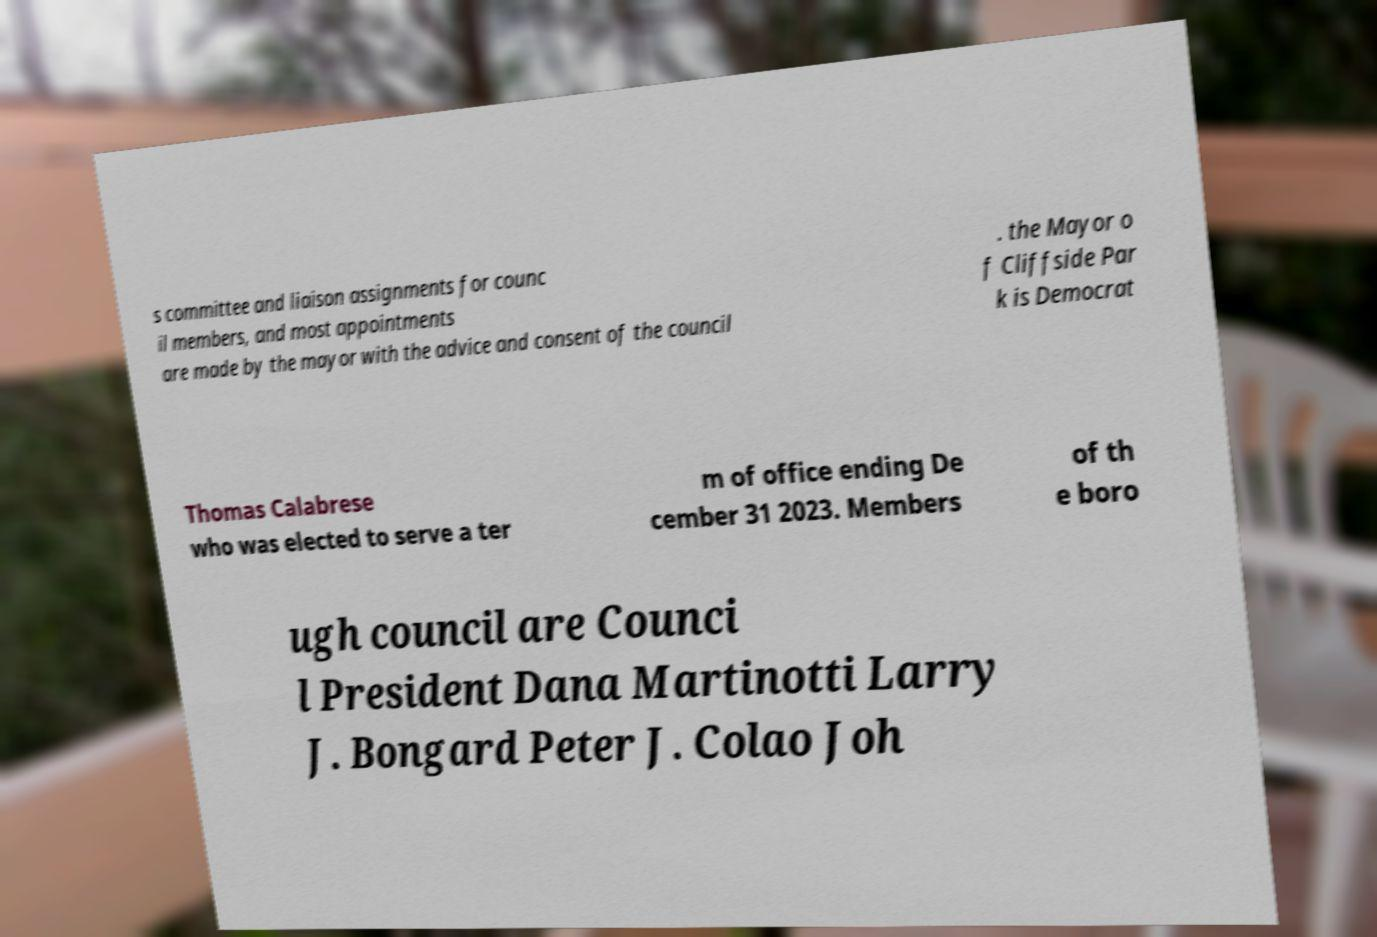For documentation purposes, I need the text within this image transcribed. Could you provide that? s committee and liaison assignments for counc il members, and most appointments are made by the mayor with the advice and consent of the council . the Mayor o f Cliffside Par k is Democrat Thomas Calabrese who was elected to serve a ter m of office ending De cember 31 2023. Members of th e boro ugh council are Counci l President Dana Martinotti Larry J. Bongard Peter J. Colao Joh 